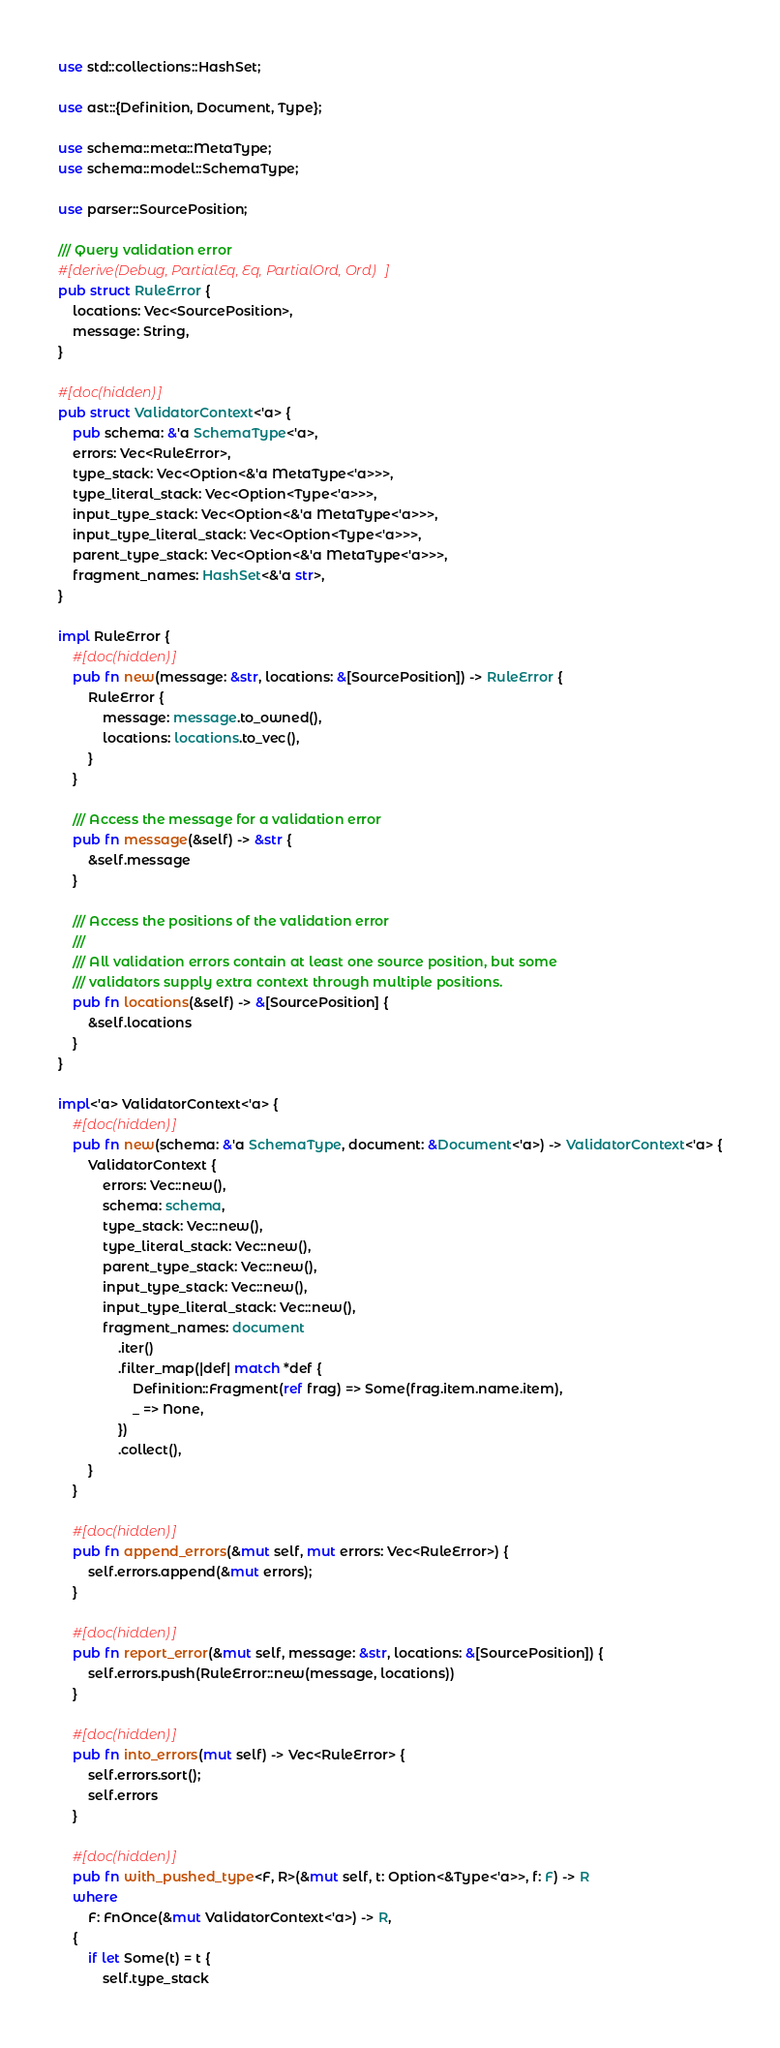Convert code to text. <code><loc_0><loc_0><loc_500><loc_500><_Rust_>use std::collections::HashSet;

use ast::{Definition, Document, Type};

use schema::meta::MetaType;
use schema::model::SchemaType;

use parser::SourcePosition;

/// Query validation error
#[derive(Debug, PartialEq, Eq, PartialOrd, Ord)]
pub struct RuleError {
    locations: Vec<SourcePosition>,
    message: String,
}

#[doc(hidden)]
pub struct ValidatorContext<'a> {
    pub schema: &'a SchemaType<'a>,
    errors: Vec<RuleError>,
    type_stack: Vec<Option<&'a MetaType<'a>>>,
    type_literal_stack: Vec<Option<Type<'a>>>,
    input_type_stack: Vec<Option<&'a MetaType<'a>>>,
    input_type_literal_stack: Vec<Option<Type<'a>>>,
    parent_type_stack: Vec<Option<&'a MetaType<'a>>>,
    fragment_names: HashSet<&'a str>,
}

impl RuleError {
    #[doc(hidden)]
    pub fn new(message: &str, locations: &[SourcePosition]) -> RuleError {
        RuleError {
            message: message.to_owned(),
            locations: locations.to_vec(),
        }
    }

    /// Access the message for a validation error
    pub fn message(&self) -> &str {
        &self.message
    }

    /// Access the positions of the validation error
    ///
    /// All validation errors contain at least one source position, but some
    /// validators supply extra context through multiple positions.
    pub fn locations(&self) -> &[SourcePosition] {
        &self.locations
    }
}

impl<'a> ValidatorContext<'a> {
    #[doc(hidden)]
    pub fn new(schema: &'a SchemaType, document: &Document<'a>) -> ValidatorContext<'a> {
        ValidatorContext {
            errors: Vec::new(),
            schema: schema,
            type_stack: Vec::new(),
            type_literal_stack: Vec::new(),
            parent_type_stack: Vec::new(),
            input_type_stack: Vec::new(),
            input_type_literal_stack: Vec::new(),
            fragment_names: document
                .iter()
                .filter_map(|def| match *def {
                    Definition::Fragment(ref frag) => Some(frag.item.name.item),
                    _ => None,
                })
                .collect(),
        }
    }

    #[doc(hidden)]
    pub fn append_errors(&mut self, mut errors: Vec<RuleError>) {
        self.errors.append(&mut errors);
    }

    #[doc(hidden)]
    pub fn report_error(&mut self, message: &str, locations: &[SourcePosition]) {
        self.errors.push(RuleError::new(message, locations))
    }

    #[doc(hidden)]
    pub fn into_errors(mut self) -> Vec<RuleError> {
        self.errors.sort();
        self.errors
    }

    #[doc(hidden)]
    pub fn with_pushed_type<F, R>(&mut self, t: Option<&Type<'a>>, f: F) -> R
    where
        F: FnOnce(&mut ValidatorContext<'a>) -> R,
    {
        if let Some(t) = t {
            self.type_stack</code> 